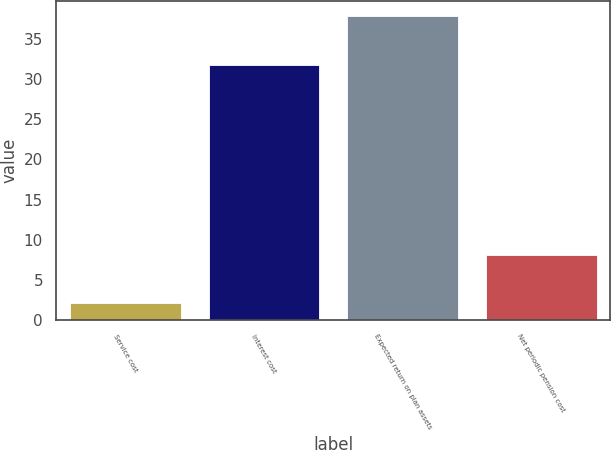<chart> <loc_0><loc_0><loc_500><loc_500><bar_chart><fcel>Service cost<fcel>Interest cost<fcel>Expected return on plan assets<fcel>Net periodic pension cost<nl><fcel>2.1<fcel>31.8<fcel>37.8<fcel>8.1<nl></chart> 